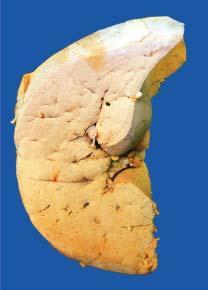what shows pale yellow parenchyma with rounded borders?
Answer the question using a single word or phrase. Sectioned slice of the liver borders 